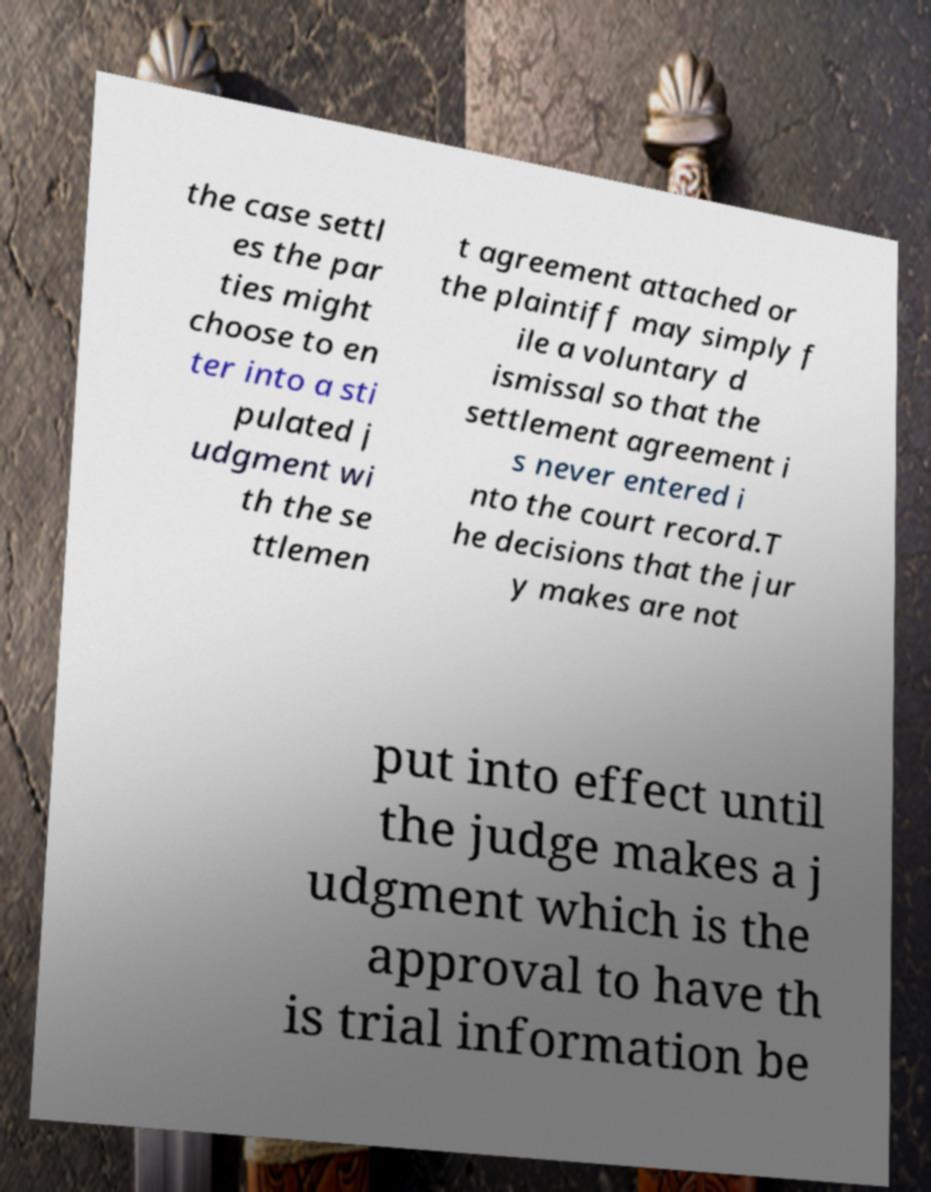For documentation purposes, I need the text within this image transcribed. Could you provide that? the case settl es the par ties might choose to en ter into a sti pulated j udgment wi th the se ttlemen t agreement attached or the plaintiff may simply f ile a voluntary d ismissal so that the settlement agreement i s never entered i nto the court record.T he decisions that the jur y makes are not put into effect until the judge makes a j udgment which is the approval to have th is trial information be 